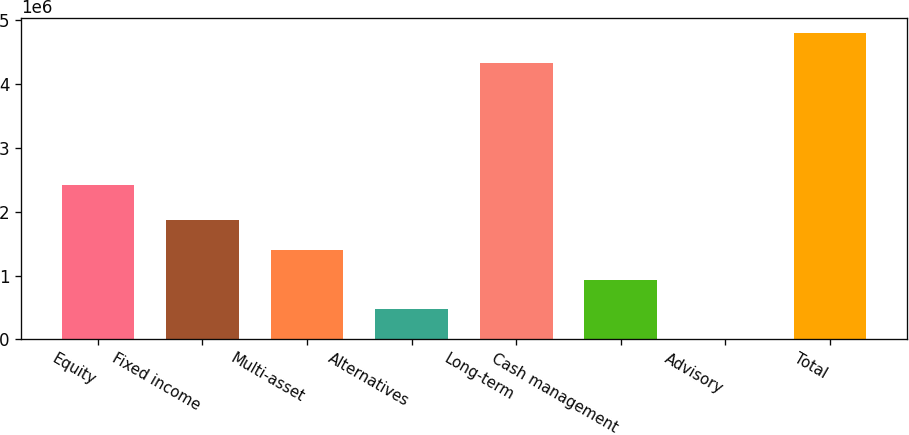Convert chart. <chart><loc_0><loc_0><loc_500><loc_500><bar_chart><fcel>Equity<fcel>Fixed income<fcel>Multi-asset<fcel>Alternatives<fcel>Long-term<fcel>Cash management<fcel>Advisory<fcel>Total<nl><fcel>2.42377e+06<fcel>1.86429e+06<fcel>1.40077e+06<fcel>473733<fcel>4.33532e+06<fcel>937253<fcel>10213<fcel>4.79883e+06<nl></chart> 